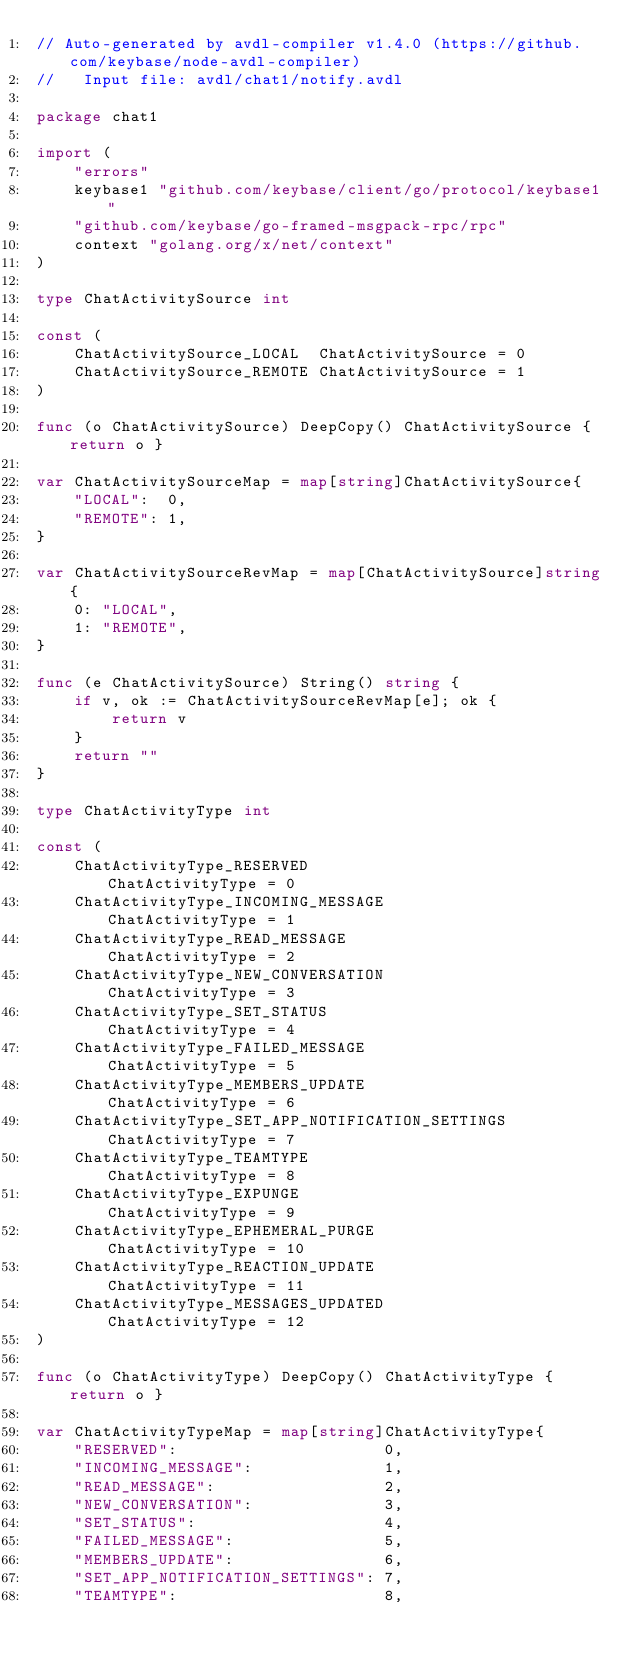Convert code to text. <code><loc_0><loc_0><loc_500><loc_500><_Go_>// Auto-generated by avdl-compiler v1.4.0 (https://github.com/keybase/node-avdl-compiler)
//   Input file: avdl/chat1/notify.avdl

package chat1

import (
	"errors"
	keybase1 "github.com/keybase/client/go/protocol/keybase1"
	"github.com/keybase/go-framed-msgpack-rpc/rpc"
	context "golang.org/x/net/context"
)

type ChatActivitySource int

const (
	ChatActivitySource_LOCAL  ChatActivitySource = 0
	ChatActivitySource_REMOTE ChatActivitySource = 1
)

func (o ChatActivitySource) DeepCopy() ChatActivitySource { return o }

var ChatActivitySourceMap = map[string]ChatActivitySource{
	"LOCAL":  0,
	"REMOTE": 1,
}

var ChatActivitySourceRevMap = map[ChatActivitySource]string{
	0: "LOCAL",
	1: "REMOTE",
}

func (e ChatActivitySource) String() string {
	if v, ok := ChatActivitySourceRevMap[e]; ok {
		return v
	}
	return ""
}

type ChatActivityType int

const (
	ChatActivityType_RESERVED                      ChatActivityType = 0
	ChatActivityType_INCOMING_MESSAGE              ChatActivityType = 1
	ChatActivityType_READ_MESSAGE                  ChatActivityType = 2
	ChatActivityType_NEW_CONVERSATION              ChatActivityType = 3
	ChatActivityType_SET_STATUS                    ChatActivityType = 4
	ChatActivityType_FAILED_MESSAGE                ChatActivityType = 5
	ChatActivityType_MEMBERS_UPDATE                ChatActivityType = 6
	ChatActivityType_SET_APP_NOTIFICATION_SETTINGS ChatActivityType = 7
	ChatActivityType_TEAMTYPE                      ChatActivityType = 8
	ChatActivityType_EXPUNGE                       ChatActivityType = 9
	ChatActivityType_EPHEMERAL_PURGE               ChatActivityType = 10
	ChatActivityType_REACTION_UPDATE               ChatActivityType = 11
	ChatActivityType_MESSAGES_UPDATED              ChatActivityType = 12
)

func (o ChatActivityType) DeepCopy() ChatActivityType { return o }

var ChatActivityTypeMap = map[string]ChatActivityType{
	"RESERVED":                      0,
	"INCOMING_MESSAGE":              1,
	"READ_MESSAGE":                  2,
	"NEW_CONVERSATION":              3,
	"SET_STATUS":                    4,
	"FAILED_MESSAGE":                5,
	"MEMBERS_UPDATE":                6,
	"SET_APP_NOTIFICATION_SETTINGS": 7,
	"TEAMTYPE":                      8,</code> 